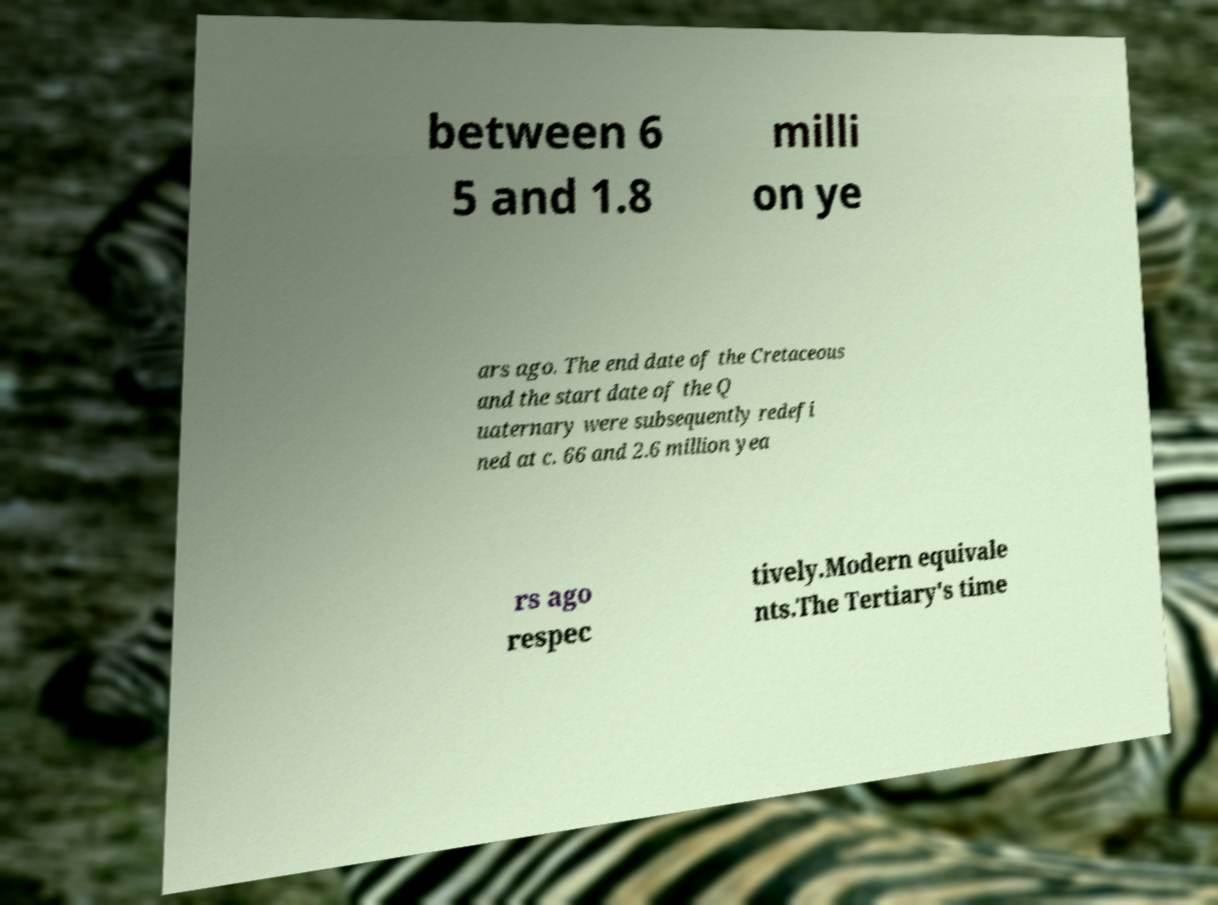What messages or text are displayed in this image? I need them in a readable, typed format. between 6 5 and 1.8 milli on ye ars ago. The end date of the Cretaceous and the start date of the Q uaternary were subsequently redefi ned at c. 66 and 2.6 million yea rs ago respec tively.Modern equivale nts.The Tertiary's time 